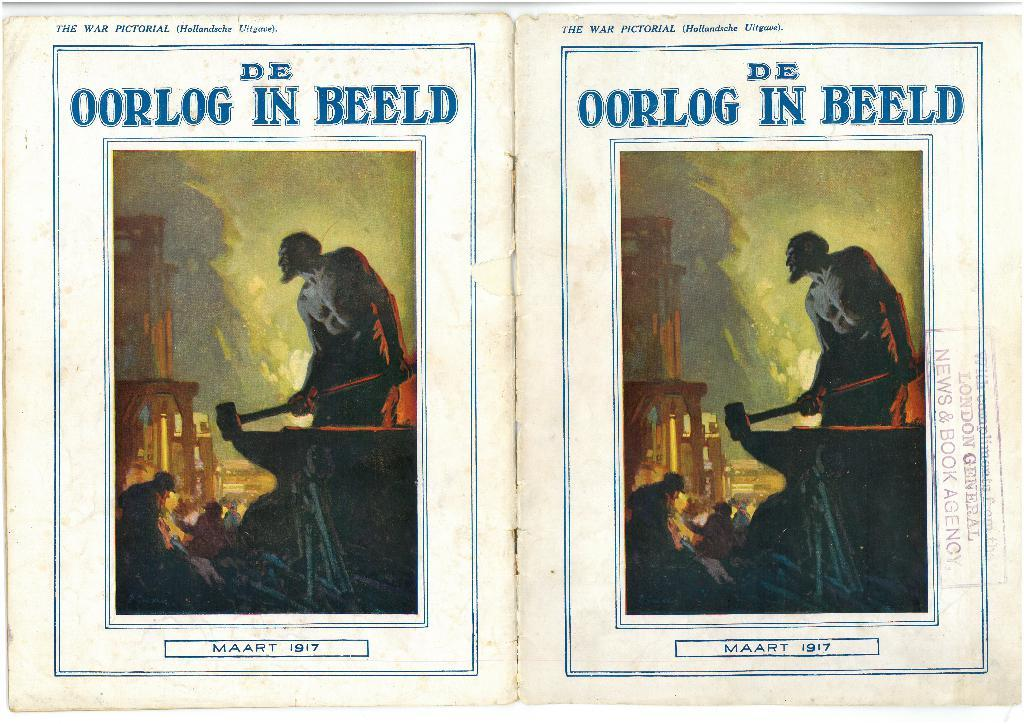<image>
Offer a succinct explanation of the picture presented. Two posters side by side with the words "De Oorlog In Beeld" on top. 